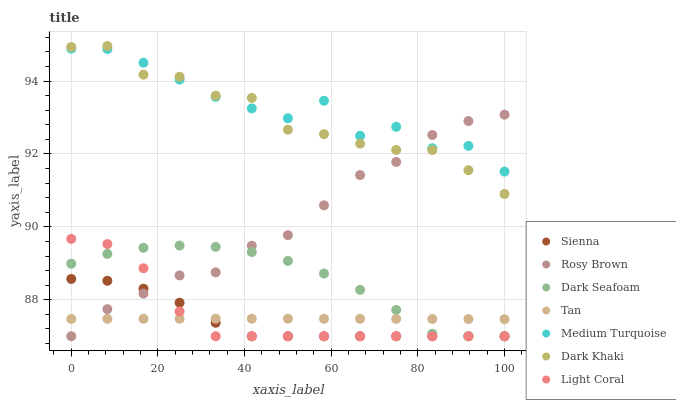Does Sienna have the minimum area under the curve?
Answer yes or no. Yes. Does Medium Turquoise have the maximum area under the curve?
Answer yes or no. Yes. Does Rosy Brown have the minimum area under the curve?
Answer yes or no. No. Does Rosy Brown have the maximum area under the curve?
Answer yes or no. No. Is Tan the smoothest?
Answer yes or no. Yes. Is Medium Turquoise the roughest?
Answer yes or no. Yes. Is Rosy Brown the smoothest?
Answer yes or no. No. Is Rosy Brown the roughest?
Answer yes or no. No. Does Rosy Brown have the lowest value?
Answer yes or no. Yes. Does Medium Turquoise have the lowest value?
Answer yes or no. No. Does Dark Khaki have the highest value?
Answer yes or no. Yes. Does Rosy Brown have the highest value?
Answer yes or no. No. Is Light Coral less than Medium Turquoise?
Answer yes or no. Yes. Is Medium Turquoise greater than Light Coral?
Answer yes or no. Yes. Does Light Coral intersect Rosy Brown?
Answer yes or no. Yes. Is Light Coral less than Rosy Brown?
Answer yes or no. No. Is Light Coral greater than Rosy Brown?
Answer yes or no. No. Does Light Coral intersect Medium Turquoise?
Answer yes or no. No. 